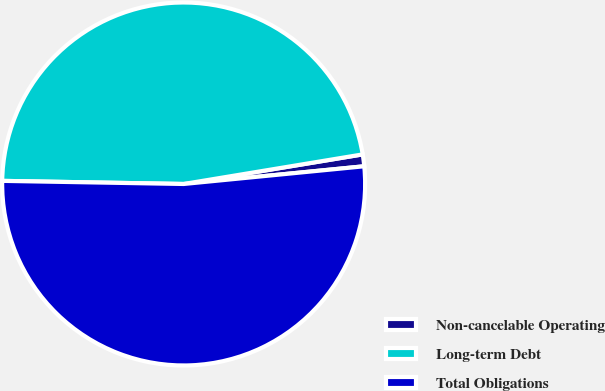Convert chart. <chart><loc_0><loc_0><loc_500><loc_500><pie_chart><fcel>Non-cancelable Operating<fcel>Long-term Debt<fcel>Total Obligations<nl><fcel>1.05%<fcel>47.12%<fcel>51.83%<nl></chart> 